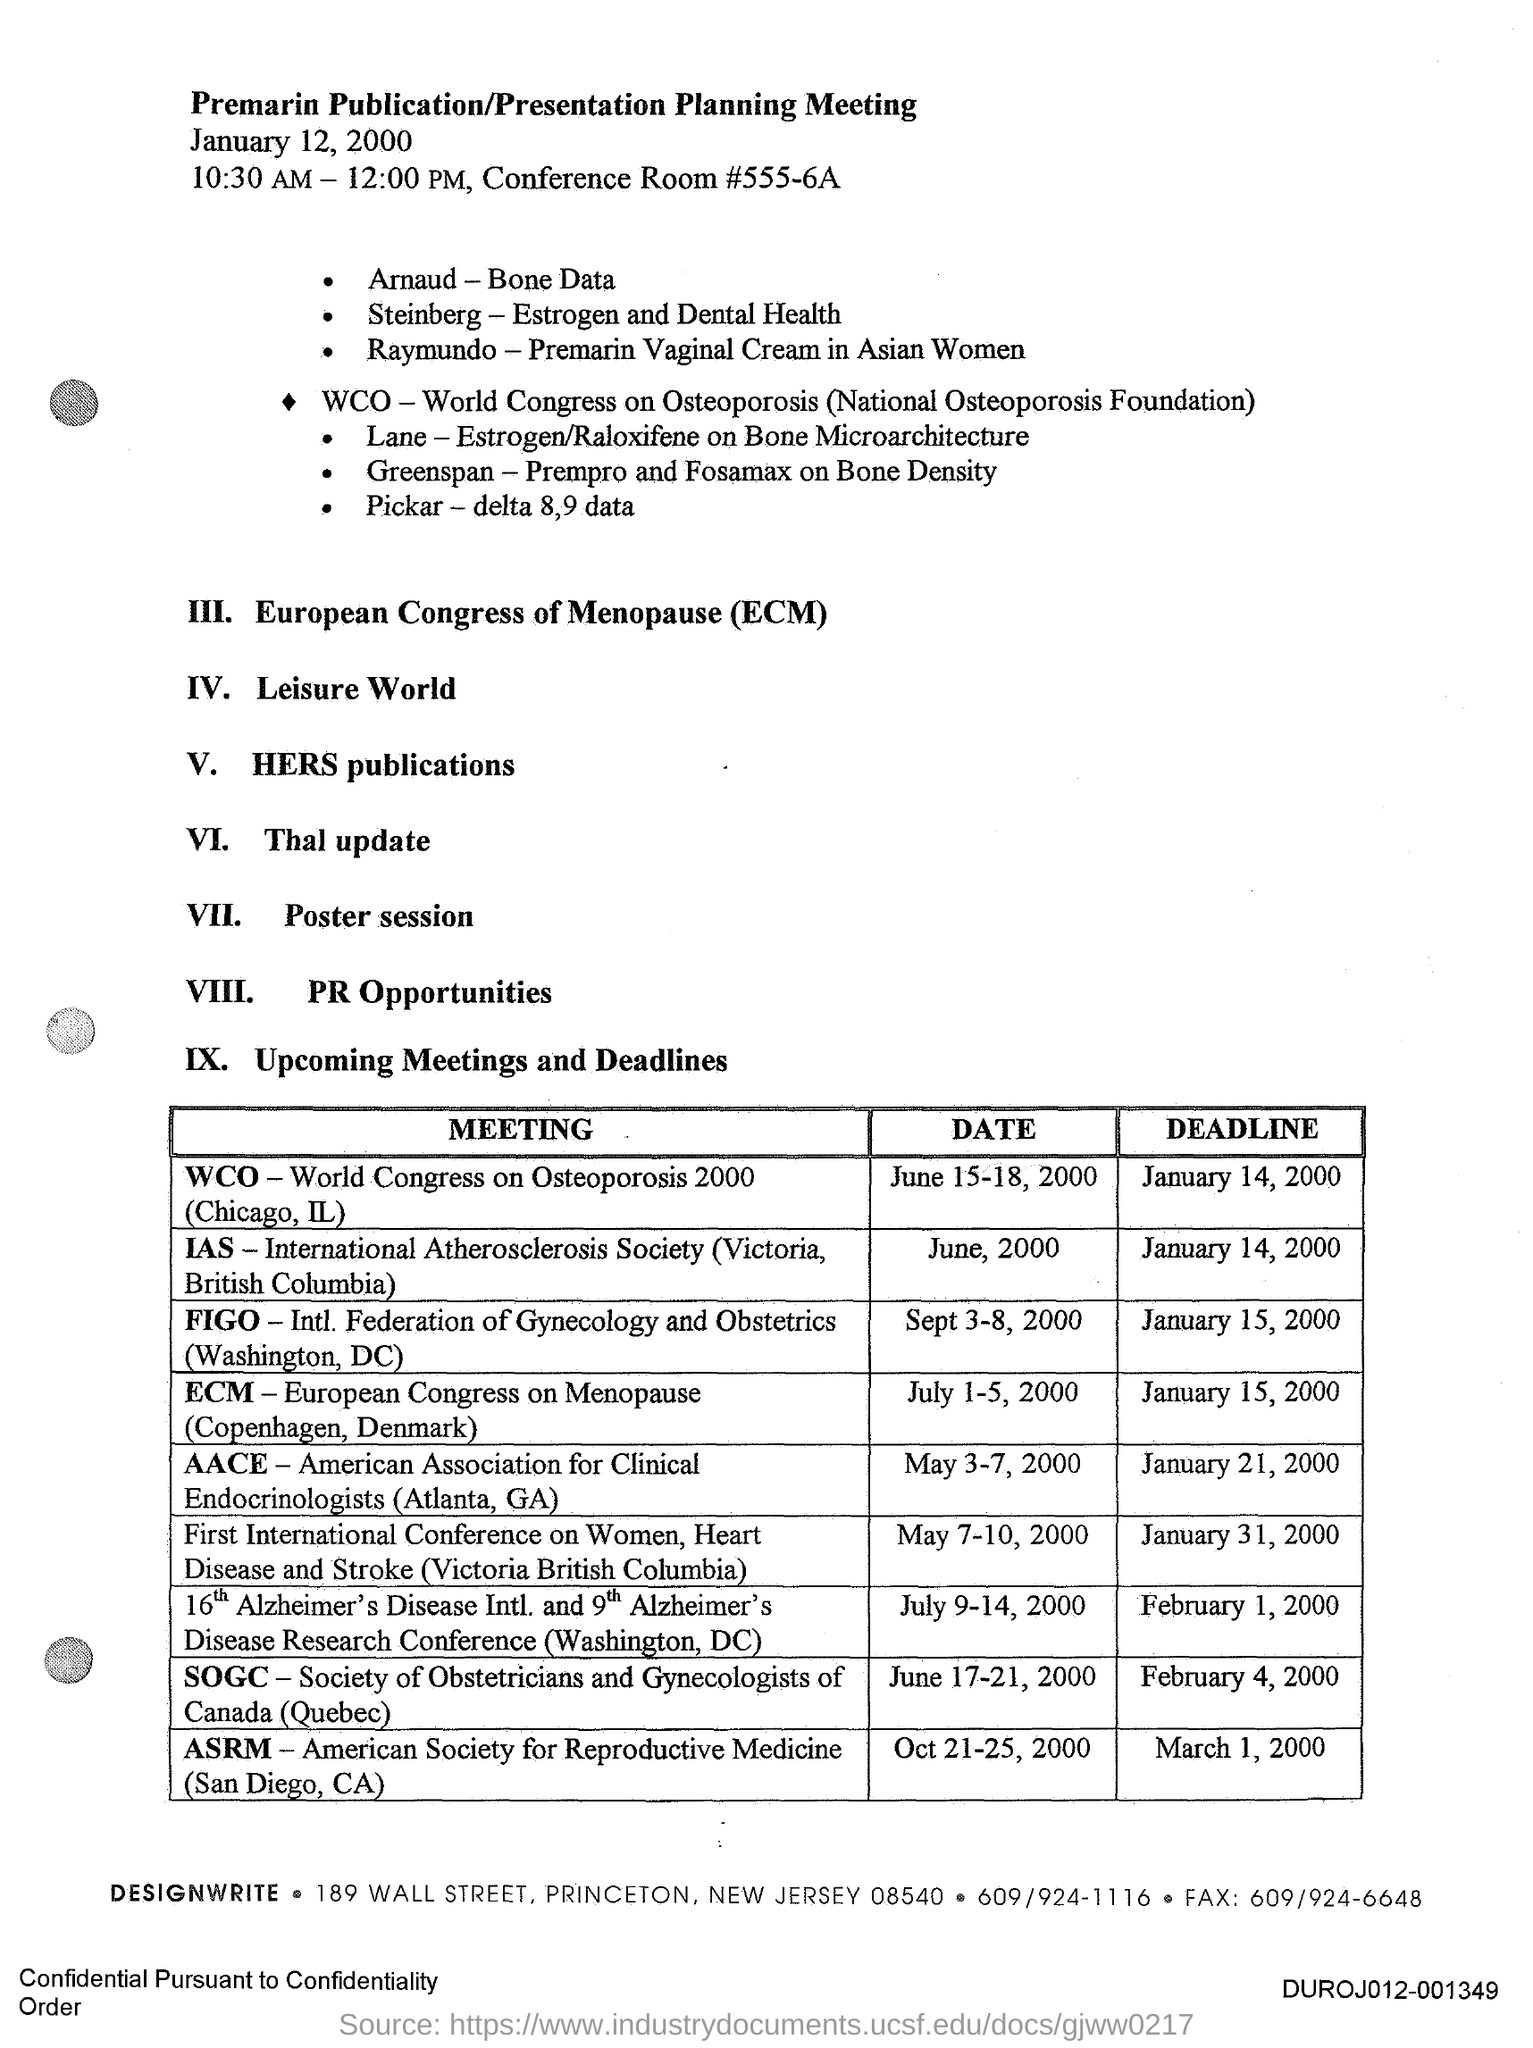Identify some key points in this picture. The Premarin Publication/Presentation Planning Meeting is held on January 12, 2000. The deadline for the Meeting titled "WCO World Congress on Osteoporosis 2000 (Chicago, IL)" is January 14, 2000. The Premarin Publication/Presentation Planning Meeting will be held at 10:30 AM - 12:00 PM. The date for the "Meeting" entitled "WCO World Congress on Osteoporosis 2000" was held from June 15 to 18, 2000, in Chicago, Illinois. 